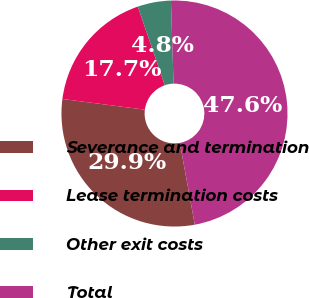Convert chart to OTSL. <chart><loc_0><loc_0><loc_500><loc_500><pie_chart><fcel>Severance and termination<fcel>Lease termination costs<fcel>Other exit costs<fcel>Total<nl><fcel>29.93%<fcel>17.69%<fcel>4.76%<fcel>47.62%<nl></chart> 